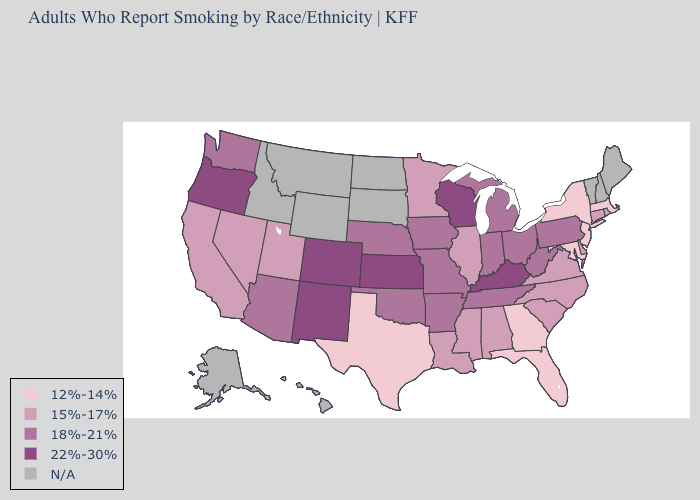What is the highest value in the South ?
Write a very short answer. 22%-30%. What is the lowest value in states that border New York?
Concise answer only. 12%-14%. What is the value of Oregon?
Be succinct. 22%-30%. Which states hav the highest value in the Northeast?
Quick response, please. Pennsylvania. What is the lowest value in the USA?
Quick response, please. 12%-14%. What is the value of Wyoming?
Short answer required. N/A. Name the states that have a value in the range 15%-17%?
Short answer required. Alabama, California, Connecticut, Delaware, Illinois, Louisiana, Minnesota, Mississippi, Nevada, North Carolina, South Carolina, Utah, Virginia. Name the states that have a value in the range 15%-17%?
Short answer required. Alabama, California, Connecticut, Delaware, Illinois, Louisiana, Minnesota, Mississippi, Nevada, North Carolina, South Carolina, Utah, Virginia. What is the value of Colorado?
Quick response, please. 22%-30%. Which states have the lowest value in the USA?
Short answer required. Florida, Georgia, Maryland, Massachusetts, New Jersey, New York, Texas. What is the value of Minnesota?
Keep it brief. 15%-17%. What is the value of Alaska?
Concise answer only. N/A. Name the states that have a value in the range 12%-14%?
Keep it brief. Florida, Georgia, Maryland, Massachusetts, New Jersey, New York, Texas. Among the states that border Massachusetts , does New York have the lowest value?
Give a very brief answer. Yes. 